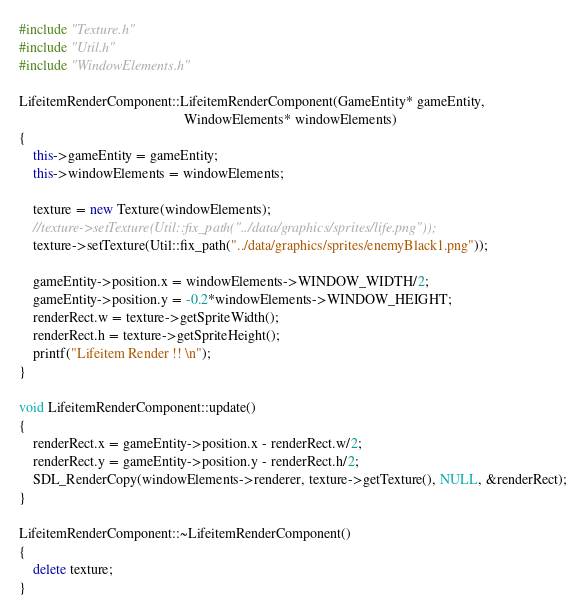Convert code to text. <code><loc_0><loc_0><loc_500><loc_500><_C++_>#include "Texture.h"
#include "Util.h"
#include "WindowElements.h"

LifeitemRenderComponent::LifeitemRenderComponent(GameEntity* gameEntity,
                                               WindowElements* windowElements)
{
    this->gameEntity = gameEntity;
    this->windowElements = windowElements;

    texture = new Texture(windowElements);
    //texture->setTexture(Util::fix_path("../data/graphics/sprites/life.png"));
    texture->setTexture(Util::fix_path("../data/graphics/sprites/enemyBlack1.png"));

    gameEntity->position.x = windowElements->WINDOW_WIDTH/2;
    gameEntity->position.y = -0.2*windowElements->WINDOW_HEIGHT;
    renderRect.w = texture->getSpriteWidth();
    renderRect.h = texture->getSpriteHeight();
    printf("Lifeitem Render !! \n");
}

void LifeitemRenderComponent::update()
{
    renderRect.x = gameEntity->position.x - renderRect.w/2;
    renderRect.y = gameEntity->position.y - renderRect.h/2;
    SDL_RenderCopy(windowElements->renderer, texture->getTexture(), NULL, &renderRect);
}

LifeitemRenderComponent::~LifeitemRenderComponent()
{
    delete texture;
}
</code> 